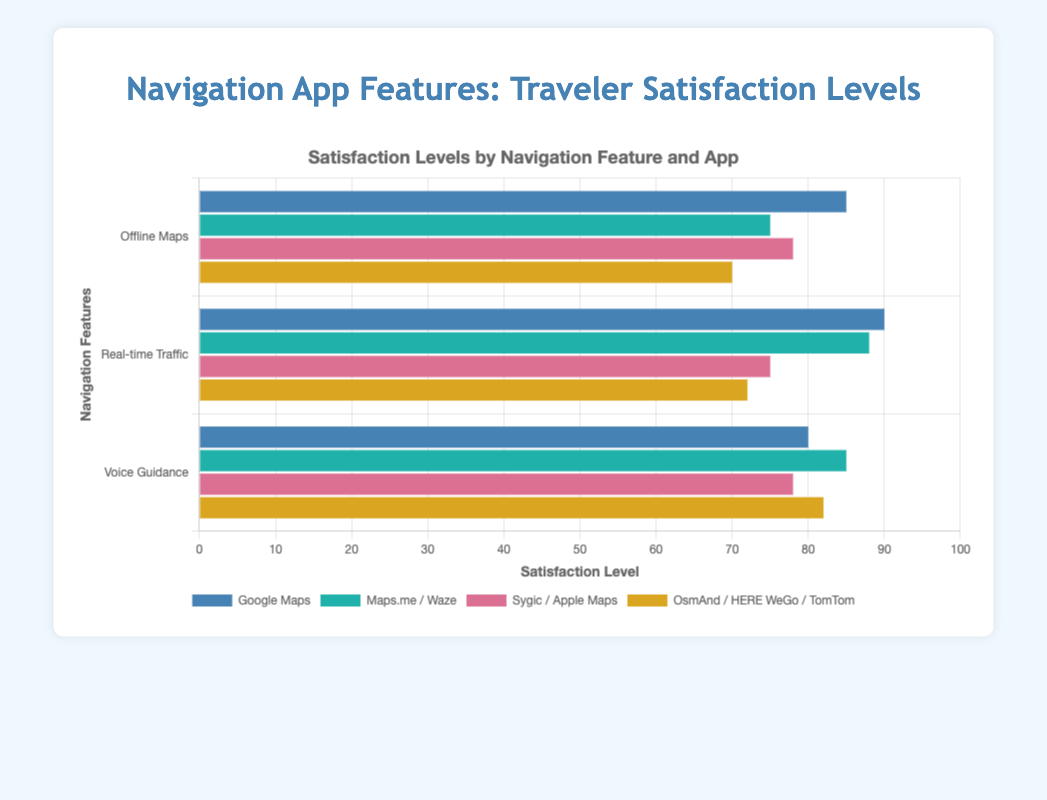Which app has the highest satisfaction level for Offline Maps? Look at the bars under the "Offline Maps" label and compare their lengths. The longest bar represents the highest satisfaction level.
Answer: Google Maps Which app shows a higher satisfaction level for Voice Guidance, Waze or TomTom? Compare the heights of the bars for Waze and TomTom under "Voice Guidance". The taller bar indicates a higher satisfaction level.
Answer: Waze What is the average satisfaction level for Real-time Traffic across all apps? Sum the satisfaction levels for all apps under "Real-time Traffic" and divide by the number of apps. (90 + 88 + 75 + 72) / 4 = 81.25
Answer: 81.25 Is the satisfaction level for Offline Maps on Google Maps greater than that on Sygic? Compare the heights of the bars for Google Maps and Sygic under "Offline Maps". Google Maps has a higher satisfaction level.
Answer: Yes Which feature has the highest overall satisfaction for Google Maps? Compare the heights of the Google Maps bars across all features and identify the tallest one.
Answer: Real-time Traffic What is the difference in satisfaction level between Google Maps and HERE WeGo for Real-time Traffic? Subtract the satisfaction level of HERE WeGo from Google Maps for Real-time Traffic. 90 - 72 = 18
Answer: 18 Which app has the lowest satisfaction for Offline Maps? Look at the bars under the "Offline Maps" label and find the shortest one.
Answer: OsmAnd What is the combined satisfaction level of Voice Guidance for Waze and TomTom? Sum the satisfaction levels for Waze and TomTom under "Voice Guidance". 85 + 82 = 167
Answer: 167 Is the satisfaction level for Real-time Traffic using Google Maps higher than the average satisfaction level for Voice Guidance across all apps? Calculate the average satisfaction level for Voice Guidance: (80 + 85 + 78 + 82) / 4 = 81.25. Compare this with Google Maps' Real-time Traffic satisfaction (90). 90 > 81.25.
Answer: Yes 